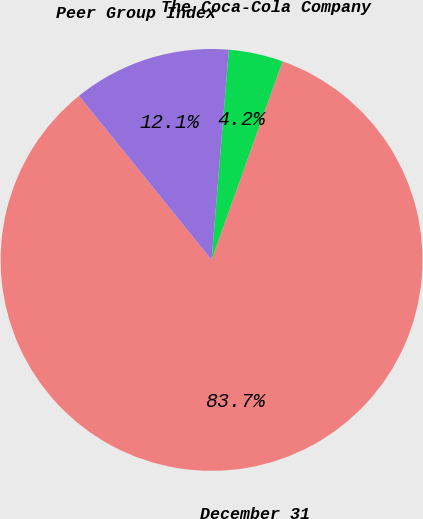Convert chart. <chart><loc_0><loc_0><loc_500><loc_500><pie_chart><fcel>December 31<fcel>The Coca-Cola Company<fcel>Peer Group Index<nl><fcel>83.72%<fcel>4.16%<fcel>12.12%<nl></chart> 